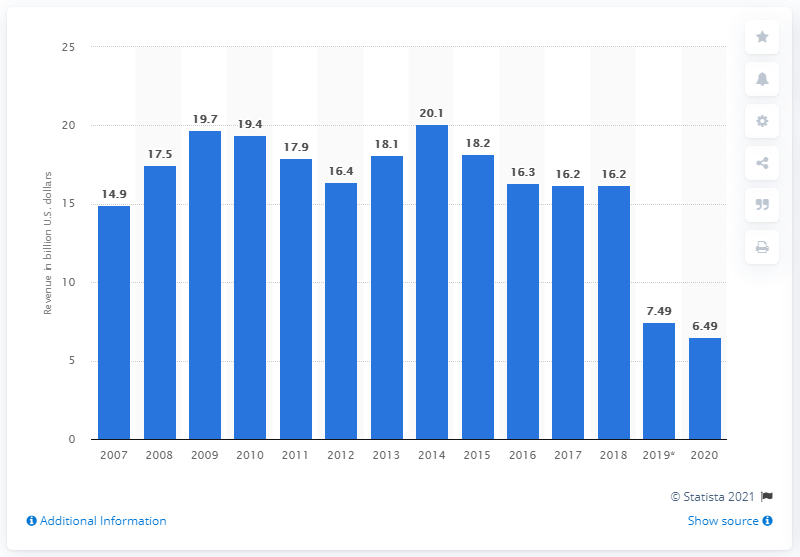List a handful of essential elements in this visual. Bombardier reported a revenue of CAD 17.2 billion in the 2020 fiscal year, which ended on December 31, 2020. 